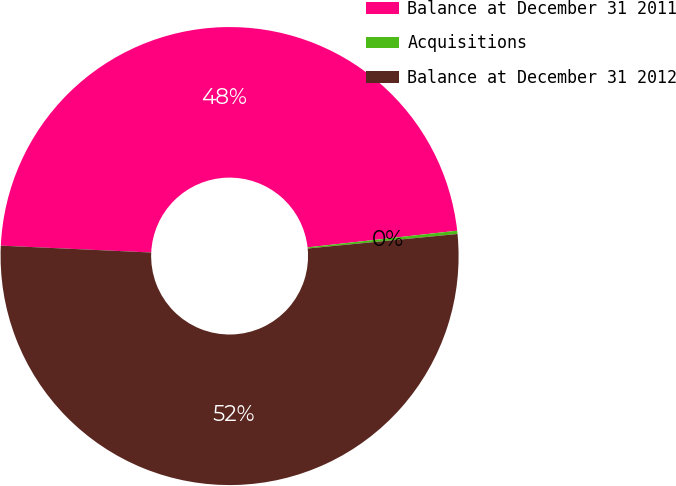Convert chart. <chart><loc_0><loc_0><loc_500><loc_500><pie_chart><fcel>Balance at December 31 2011<fcel>Acquisitions<fcel>Balance at December 31 2012<nl><fcel>47.51%<fcel>0.23%<fcel>52.26%<nl></chart> 